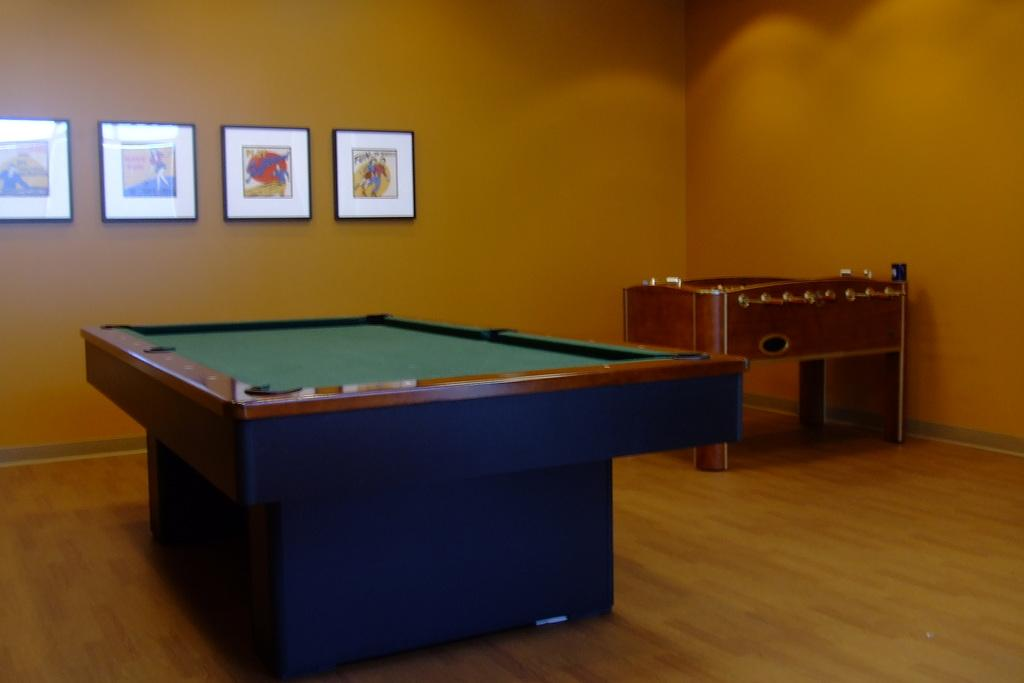What type of table is in the image? There is a snooker table in the image. What can be seen on the walls in the background of the image? There are paintings on the wall in the background of the image. How does the fear of snakes affect the game of snooker in the image? There is no fear of snakes or any indication of fear in the image; it simply features a snooker table and paintings on the wall. 